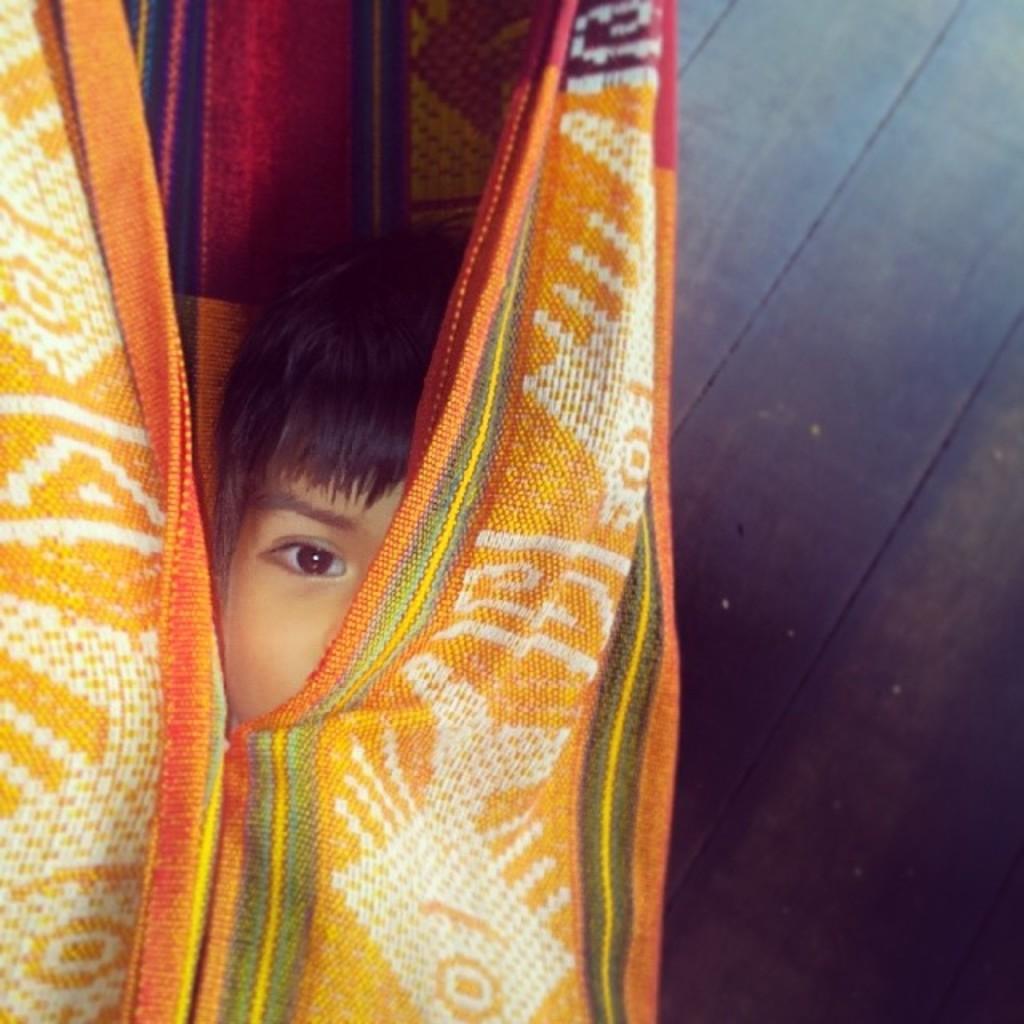In one or two sentences, can you explain what this image depicts? Towards left we can see a kid in a cloth. On the right it is floor. 